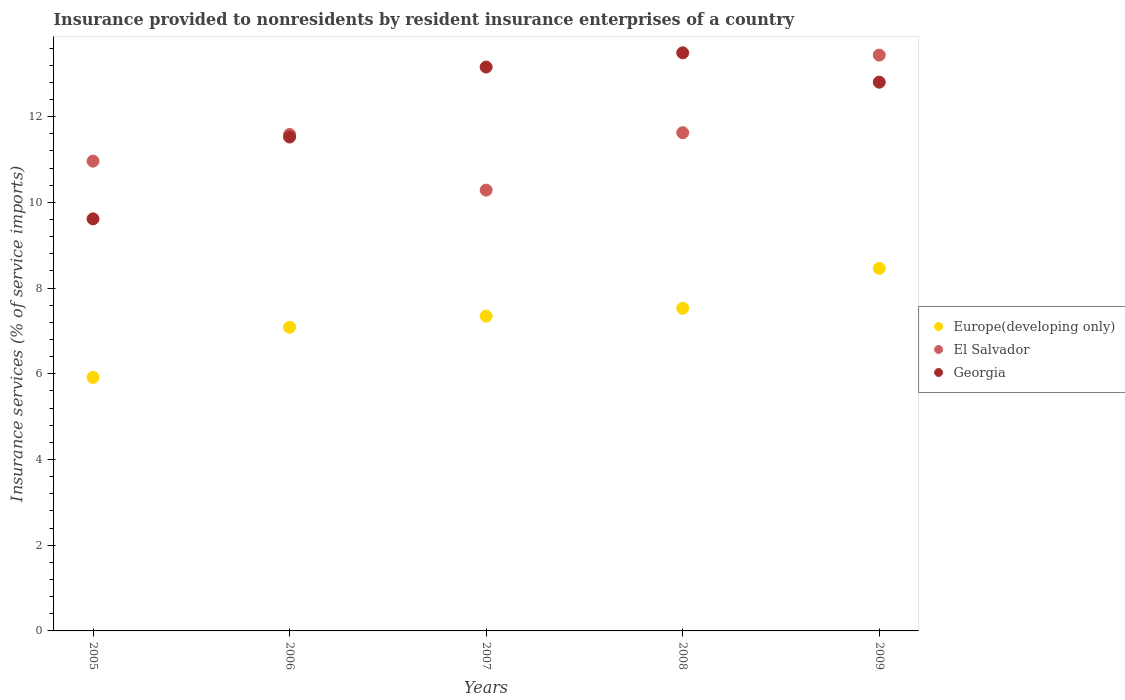How many different coloured dotlines are there?
Make the answer very short. 3. Is the number of dotlines equal to the number of legend labels?
Make the answer very short. Yes. What is the insurance provided to nonresidents in Georgia in 2007?
Provide a short and direct response. 13.16. Across all years, what is the maximum insurance provided to nonresidents in El Salvador?
Give a very brief answer. 13.44. Across all years, what is the minimum insurance provided to nonresidents in Georgia?
Offer a very short reply. 9.62. What is the total insurance provided to nonresidents in Georgia in the graph?
Offer a terse response. 60.59. What is the difference between the insurance provided to nonresidents in Europe(developing only) in 2005 and that in 2006?
Provide a short and direct response. -1.17. What is the difference between the insurance provided to nonresidents in El Salvador in 2007 and the insurance provided to nonresidents in Europe(developing only) in 2009?
Provide a short and direct response. 1.83. What is the average insurance provided to nonresidents in El Salvador per year?
Ensure brevity in your answer.  11.58. In the year 2007, what is the difference between the insurance provided to nonresidents in Georgia and insurance provided to nonresidents in El Salvador?
Your response must be concise. 2.87. What is the ratio of the insurance provided to nonresidents in El Salvador in 2008 to that in 2009?
Offer a very short reply. 0.87. What is the difference between the highest and the second highest insurance provided to nonresidents in Europe(developing only)?
Offer a very short reply. 0.93. What is the difference between the highest and the lowest insurance provided to nonresidents in El Salvador?
Your answer should be very brief. 3.15. In how many years, is the insurance provided to nonresidents in El Salvador greater than the average insurance provided to nonresidents in El Salvador taken over all years?
Offer a terse response. 3. Is the sum of the insurance provided to nonresidents in Europe(developing only) in 2007 and 2009 greater than the maximum insurance provided to nonresidents in Georgia across all years?
Make the answer very short. Yes. Is the insurance provided to nonresidents in Georgia strictly less than the insurance provided to nonresidents in Europe(developing only) over the years?
Your response must be concise. No. Are the values on the major ticks of Y-axis written in scientific E-notation?
Offer a terse response. No. Does the graph contain grids?
Your answer should be compact. No. How many legend labels are there?
Ensure brevity in your answer.  3. How are the legend labels stacked?
Offer a terse response. Vertical. What is the title of the graph?
Offer a terse response. Insurance provided to nonresidents by resident insurance enterprises of a country. Does "Brazil" appear as one of the legend labels in the graph?
Provide a short and direct response. No. What is the label or title of the X-axis?
Keep it short and to the point. Years. What is the label or title of the Y-axis?
Provide a succinct answer. Insurance services (% of service imports). What is the Insurance services (% of service imports) in Europe(developing only) in 2005?
Offer a very short reply. 5.92. What is the Insurance services (% of service imports) of El Salvador in 2005?
Ensure brevity in your answer.  10.96. What is the Insurance services (% of service imports) in Georgia in 2005?
Provide a succinct answer. 9.62. What is the Insurance services (% of service imports) in Europe(developing only) in 2006?
Give a very brief answer. 7.09. What is the Insurance services (% of service imports) in El Salvador in 2006?
Provide a succinct answer. 11.59. What is the Insurance services (% of service imports) in Georgia in 2006?
Ensure brevity in your answer.  11.53. What is the Insurance services (% of service imports) in Europe(developing only) in 2007?
Offer a very short reply. 7.34. What is the Insurance services (% of service imports) in El Salvador in 2007?
Provide a succinct answer. 10.29. What is the Insurance services (% of service imports) in Georgia in 2007?
Keep it short and to the point. 13.16. What is the Insurance services (% of service imports) of Europe(developing only) in 2008?
Your response must be concise. 7.53. What is the Insurance services (% of service imports) in El Salvador in 2008?
Ensure brevity in your answer.  11.63. What is the Insurance services (% of service imports) of Georgia in 2008?
Give a very brief answer. 13.49. What is the Insurance services (% of service imports) in Europe(developing only) in 2009?
Your answer should be compact. 8.46. What is the Insurance services (% of service imports) of El Salvador in 2009?
Your response must be concise. 13.44. What is the Insurance services (% of service imports) of Georgia in 2009?
Make the answer very short. 12.8. Across all years, what is the maximum Insurance services (% of service imports) of Europe(developing only)?
Provide a succinct answer. 8.46. Across all years, what is the maximum Insurance services (% of service imports) in El Salvador?
Your answer should be very brief. 13.44. Across all years, what is the maximum Insurance services (% of service imports) in Georgia?
Provide a succinct answer. 13.49. Across all years, what is the minimum Insurance services (% of service imports) in Europe(developing only)?
Provide a short and direct response. 5.92. Across all years, what is the minimum Insurance services (% of service imports) in El Salvador?
Keep it short and to the point. 10.29. Across all years, what is the minimum Insurance services (% of service imports) of Georgia?
Ensure brevity in your answer.  9.62. What is the total Insurance services (% of service imports) in Europe(developing only) in the graph?
Your answer should be compact. 36.34. What is the total Insurance services (% of service imports) of El Salvador in the graph?
Your answer should be very brief. 57.9. What is the total Insurance services (% of service imports) of Georgia in the graph?
Make the answer very short. 60.59. What is the difference between the Insurance services (% of service imports) of Europe(developing only) in 2005 and that in 2006?
Offer a terse response. -1.17. What is the difference between the Insurance services (% of service imports) in El Salvador in 2005 and that in 2006?
Give a very brief answer. -0.62. What is the difference between the Insurance services (% of service imports) in Georgia in 2005 and that in 2006?
Your answer should be compact. -1.91. What is the difference between the Insurance services (% of service imports) in Europe(developing only) in 2005 and that in 2007?
Keep it short and to the point. -1.43. What is the difference between the Insurance services (% of service imports) of El Salvador in 2005 and that in 2007?
Provide a succinct answer. 0.68. What is the difference between the Insurance services (% of service imports) of Georgia in 2005 and that in 2007?
Your answer should be very brief. -3.54. What is the difference between the Insurance services (% of service imports) of Europe(developing only) in 2005 and that in 2008?
Your answer should be very brief. -1.61. What is the difference between the Insurance services (% of service imports) of El Salvador in 2005 and that in 2008?
Your answer should be very brief. -0.66. What is the difference between the Insurance services (% of service imports) in Georgia in 2005 and that in 2008?
Ensure brevity in your answer.  -3.87. What is the difference between the Insurance services (% of service imports) in Europe(developing only) in 2005 and that in 2009?
Ensure brevity in your answer.  -2.54. What is the difference between the Insurance services (% of service imports) in El Salvador in 2005 and that in 2009?
Your answer should be very brief. -2.47. What is the difference between the Insurance services (% of service imports) of Georgia in 2005 and that in 2009?
Keep it short and to the point. -3.19. What is the difference between the Insurance services (% of service imports) of Europe(developing only) in 2006 and that in 2007?
Offer a very short reply. -0.26. What is the difference between the Insurance services (% of service imports) in El Salvador in 2006 and that in 2007?
Offer a very short reply. 1.3. What is the difference between the Insurance services (% of service imports) of Georgia in 2006 and that in 2007?
Make the answer very short. -1.63. What is the difference between the Insurance services (% of service imports) of Europe(developing only) in 2006 and that in 2008?
Your response must be concise. -0.44. What is the difference between the Insurance services (% of service imports) of El Salvador in 2006 and that in 2008?
Keep it short and to the point. -0.04. What is the difference between the Insurance services (% of service imports) in Georgia in 2006 and that in 2008?
Provide a short and direct response. -1.96. What is the difference between the Insurance services (% of service imports) in Europe(developing only) in 2006 and that in 2009?
Give a very brief answer. -1.37. What is the difference between the Insurance services (% of service imports) of El Salvador in 2006 and that in 2009?
Ensure brevity in your answer.  -1.85. What is the difference between the Insurance services (% of service imports) in Georgia in 2006 and that in 2009?
Offer a very short reply. -1.28. What is the difference between the Insurance services (% of service imports) of Europe(developing only) in 2007 and that in 2008?
Provide a succinct answer. -0.18. What is the difference between the Insurance services (% of service imports) of El Salvador in 2007 and that in 2008?
Provide a succinct answer. -1.34. What is the difference between the Insurance services (% of service imports) of Georgia in 2007 and that in 2008?
Give a very brief answer. -0.33. What is the difference between the Insurance services (% of service imports) in Europe(developing only) in 2007 and that in 2009?
Provide a short and direct response. -1.12. What is the difference between the Insurance services (% of service imports) in El Salvador in 2007 and that in 2009?
Your response must be concise. -3.15. What is the difference between the Insurance services (% of service imports) of Georgia in 2007 and that in 2009?
Provide a succinct answer. 0.35. What is the difference between the Insurance services (% of service imports) of Europe(developing only) in 2008 and that in 2009?
Ensure brevity in your answer.  -0.93. What is the difference between the Insurance services (% of service imports) of El Salvador in 2008 and that in 2009?
Ensure brevity in your answer.  -1.81. What is the difference between the Insurance services (% of service imports) of Georgia in 2008 and that in 2009?
Your answer should be very brief. 0.69. What is the difference between the Insurance services (% of service imports) in Europe(developing only) in 2005 and the Insurance services (% of service imports) in El Salvador in 2006?
Keep it short and to the point. -5.67. What is the difference between the Insurance services (% of service imports) of Europe(developing only) in 2005 and the Insurance services (% of service imports) of Georgia in 2006?
Ensure brevity in your answer.  -5.61. What is the difference between the Insurance services (% of service imports) of El Salvador in 2005 and the Insurance services (% of service imports) of Georgia in 2006?
Make the answer very short. -0.56. What is the difference between the Insurance services (% of service imports) of Europe(developing only) in 2005 and the Insurance services (% of service imports) of El Salvador in 2007?
Your answer should be compact. -4.37. What is the difference between the Insurance services (% of service imports) in Europe(developing only) in 2005 and the Insurance services (% of service imports) in Georgia in 2007?
Give a very brief answer. -7.24. What is the difference between the Insurance services (% of service imports) of El Salvador in 2005 and the Insurance services (% of service imports) of Georgia in 2007?
Make the answer very short. -2.2. What is the difference between the Insurance services (% of service imports) of Europe(developing only) in 2005 and the Insurance services (% of service imports) of El Salvador in 2008?
Offer a very short reply. -5.71. What is the difference between the Insurance services (% of service imports) of Europe(developing only) in 2005 and the Insurance services (% of service imports) of Georgia in 2008?
Provide a short and direct response. -7.57. What is the difference between the Insurance services (% of service imports) in El Salvador in 2005 and the Insurance services (% of service imports) in Georgia in 2008?
Your response must be concise. -2.53. What is the difference between the Insurance services (% of service imports) in Europe(developing only) in 2005 and the Insurance services (% of service imports) in El Salvador in 2009?
Offer a terse response. -7.52. What is the difference between the Insurance services (% of service imports) of Europe(developing only) in 2005 and the Insurance services (% of service imports) of Georgia in 2009?
Your answer should be compact. -6.89. What is the difference between the Insurance services (% of service imports) in El Salvador in 2005 and the Insurance services (% of service imports) in Georgia in 2009?
Provide a short and direct response. -1.84. What is the difference between the Insurance services (% of service imports) in Europe(developing only) in 2006 and the Insurance services (% of service imports) in El Salvador in 2007?
Your answer should be compact. -3.2. What is the difference between the Insurance services (% of service imports) of Europe(developing only) in 2006 and the Insurance services (% of service imports) of Georgia in 2007?
Ensure brevity in your answer.  -6.07. What is the difference between the Insurance services (% of service imports) of El Salvador in 2006 and the Insurance services (% of service imports) of Georgia in 2007?
Your answer should be compact. -1.57. What is the difference between the Insurance services (% of service imports) in Europe(developing only) in 2006 and the Insurance services (% of service imports) in El Salvador in 2008?
Provide a succinct answer. -4.54. What is the difference between the Insurance services (% of service imports) of Europe(developing only) in 2006 and the Insurance services (% of service imports) of Georgia in 2008?
Make the answer very short. -6.4. What is the difference between the Insurance services (% of service imports) of El Salvador in 2006 and the Insurance services (% of service imports) of Georgia in 2008?
Offer a very short reply. -1.9. What is the difference between the Insurance services (% of service imports) of Europe(developing only) in 2006 and the Insurance services (% of service imports) of El Salvador in 2009?
Provide a short and direct response. -6.35. What is the difference between the Insurance services (% of service imports) in Europe(developing only) in 2006 and the Insurance services (% of service imports) in Georgia in 2009?
Provide a short and direct response. -5.72. What is the difference between the Insurance services (% of service imports) of El Salvador in 2006 and the Insurance services (% of service imports) of Georgia in 2009?
Provide a short and direct response. -1.22. What is the difference between the Insurance services (% of service imports) in Europe(developing only) in 2007 and the Insurance services (% of service imports) in El Salvador in 2008?
Your answer should be very brief. -4.28. What is the difference between the Insurance services (% of service imports) of Europe(developing only) in 2007 and the Insurance services (% of service imports) of Georgia in 2008?
Make the answer very short. -6.15. What is the difference between the Insurance services (% of service imports) of El Salvador in 2007 and the Insurance services (% of service imports) of Georgia in 2008?
Your answer should be compact. -3.2. What is the difference between the Insurance services (% of service imports) of Europe(developing only) in 2007 and the Insurance services (% of service imports) of El Salvador in 2009?
Offer a very short reply. -6.09. What is the difference between the Insurance services (% of service imports) in Europe(developing only) in 2007 and the Insurance services (% of service imports) in Georgia in 2009?
Keep it short and to the point. -5.46. What is the difference between the Insurance services (% of service imports) of El Salvador in 2007 and the Insurance services (% of service imports) of Georgia in 2009?
Offer a very short reply. -2.52. What is the difference between the Insurance services (% of service imports) in Europe(developing only) in 2008 and the Insurance services (% of service imports) in El Salvador in 2009?
Your answer should be compact. -5.91. What is the difference between the Insurance services (% of service imports) of Europe(developing only) in 2008 and the Insurance services (% of service imports) of Georgia in 2009?
Your answer should be very brief. -5.28. What is the difference between the Insurance services (% of service imports) in El Salvador in 2008 and the Insurance services (% of service imports) in Georgia in 2009?
Provide a short and direct response. -1.18. What is the average Insurance services (% of service imports) of Europe(developing only) per year?
Give a very brief answer. 7.27. What is the average Insurance services (% of service imports) in El Salvador per year?
Provide a succinct answer. 11.58. What is the average Insurance services (% of service imports) in Georgia per year?
Provide a succinct answer. 12.12. In the year 2005, what is the difference between the Insurance services (% of service imports) in Europe(developing only) and Insurance services (% of service imports) in El Salvador?
Make the answer very short. -5.05. In the year 2005, what is the difference between the Insurance services (% of service imports) in Europe(developing only) and Insurance services (% of service imports) in Georgia?
Offer a terse response. -3.7. In the year 2005, what is the difference between the Insurance services (% of service imports) of El Salvador and Insurance services (% of service imports) of Georgia?
Your answer should be compact. 1.35. In the year 2006, what is the difference between the Insurance services (% of service imports) of Europe(developing only) and Insurance services (% of service imports) of Georgia?
Your answer should be compact. -4.44. In the year 2006, what is the difference between the Insurance services (% of service imports) of El Salvador and Insurance services (% of service imports) of Georgia?
Provide a short and direct response. 0.06. In the year 2007, what is the difference between the Insurance services (% of service imports) in Europe(developing only) and Insurance services (% of service imports) in El Salvador?
Ensure brevity in your answer.  -2.94. In the year 2007, what is the difference between the Insurance services (% of service imports) in Europe(developing only) and Insurance services (% of service imports) in Georgia?
Give a very brief answer. -5.81. In the year 2007, what is the difference between the Insurance services (% of service imports) in El Salvador and Insurance services (% of service imports) in Georgia?
Your answer should be very brief. -2.87. In the year 2008, what is the difference between the Insurance services (% of service imports) in Europe(developing only) and Insurance services (% of service imports) in El Salvador?
Your response must be concise. -4.1. In the year 2008, what is the difference between the Insurance services (% of service imports) of Europe(developing only) and Insurance services (% of service imports) of Georgia?
Your answer should be very brief. -5.96. In the year 2008, what is the difference between the Insurance services (% of service imports) of El Salvador and Insurance services (% of service imports) of Georgia?
Offer a very short reply. -1.86. In the year 2009, what is the difference between the Insurance services (% of service imports) of Europe(developing only) and Insurance services (% of service imports) of El Salvador?
Ensure brevity in your answer.  -4.98. In the year 2009, what is the difference between the Insurance services (% of service imports) of Europe(developing only) and Insurance services (% of service imports) of Georgia?
Make the answer very short. -4.34. In the year 2009, what is the difference between the Insurance services (% of service imports) in El Salvador and Insurance services (% of service imports) in Georgia?
Offer a terse response. 0.63. What is the ratio of the Insurance services (% of service imports) of Europe(developing only) in 2005 to that in 2006?
Ensure brevity in your answer.  0.84. What is the ratio of the Insurance services (% of service imports) of El Salvador in 2005 to that in 2006?
Offer a very short reply. 0.95. What is the ratio of the Insurance services (% of service imports) in Georgia in 2005 to that in 2006?
Your answer should be very brief. 0.83. What is the ratio of the Insurance services (% of service imports) of Europe(developing only) in 2005 to that in 2007?
Your answer should be compact. 0.81. What is the ratio of the Insurance services (% of service imports) of El Salvador in 2005 to that in 2007?
Provide a short and direct response. 1.07. What is the ratio of the Insurance services (% of service imports) in Georgia in 2005 to that in 2007?
Ensure brevity in your answer.  0.73. What is the ratio of the Insurance services (% of service imports) in Europe(developing only) in 2005 to that in 2008?
Make the answer very short. 0.79. What is the ratio of the Insurance services (% of service imports) of El Salvador in 2005 to that in 2008?
Your response must be concise. 0.94. What is the ratio of the Insurance services (% of service imports) in Georgia in 2005 to that in 2008?
Offer a very short reply. 0.71. What is the ratio of the Insurance services (% of service imports) of Europe(developing only) in 2005 to that in 2009?
Make the answer very short. 0.7. What is the ratio of the Insurance services (% of service imports) of El Salvador in 2005 to that in 2009?
Your response must be concise. 0.82. What is the ratio of the Insurance services (% of service imports) in Georgia in 2005 to that in 2009?
Give a very brief answer. 0.75. What is the ratio of the Insurance services (% of service imports) in Europe(developing only) in 2006 to that in 2007?
Offer a terse response. 0.96. What is the ratio of the Insurance services (% of service imports) in El Salvador in 2006 to that in 2007?
Your answer should be very brief. 1.13. What is the ratio of the Insurance services (% of service imports) of Georgia in 2006 to that in 2007?
Offer a very short reply. 0.88. What is the ratio of the Insurance services (% of service imports) of Europe(developing only) in 2006 to that in 2008?
Provide a short and direct response. 0.94. What is the ratio of the Insurance services (% of service imports) in El Salvador in 2006 to that in 2008?
Your answer should be very brief. 1. What is the ratio of the Insurance services (% of service imports) of Georgia in 2006 to that in 2008?
Offer a very short reply. 0.85. What is the ratio of the Insurance services (% of service imports) of Europe(developing only) in 2006 to that in 2009?
Your answer should be very brief. 0.84. What is the ratio of the Insurance services (% of service imports) in El Salvador in 2006 to that in 2009?
Offer a terse response. 0.86. What is the ratio of the Insurance services (% of service imports) of Georgia in 2006 to that in 2009?
Keep it short and to the point. 0.9. What is the ratio of the Insurance services (% of service imports) of Europe(developing only) in 2007 to that in 2008?
Ensure brevity in your answer.  0.98. What is the ratio of the Insurance services (% of service imports) in El Salvador in 2007 to that in 2008?
Offer a terse response. 0.88. What is the ratio of the Insurance services (% of service imports) of Georgia in 2007 to that in 2008?
Your response must be concise. 0.98. What is the ratio of the Insurance services (% of service imports) in Europe(developing only) in 2007 to that in 2009?
Ensure brevity in your answer.  0.87. What is the ratio of the Insurance services (% of service imports) of El Salvador in 2007 to that in 2009?
Make the answer very short. 0.77. What is the ratio of the Insurance services (% of service imports) of Georgia in 2007 to that in 2009?
Keep it short and to the point. 1.03. What is the ratio of the Insurance services (% of service imports) of Europe(developing only) in 2008 to that in 2009?
Provide a succinct answer. 0.89. What is the ratio of the Insurance services (% of service imports) of El Salvador in 2008 to that in 2009?
Keep it short and to the point. 0.87. What is the ratio of the Insurance services (% of service imports) in Georgia in 2008 to that in 2009?
Offer a terse response. 1.05. What is the difference between the highest and the second highest Insurance services (% of service imports) in Europe(developing only)?
Your answer should be very brief. 0.93. What is the difference between the highest and the second highest Insurance services (% of service imports) of El Salvador?
Give a very brief answer. 1.81. What is the difference between the highest and the second highest Insurance services (% of service imports) of Georgia?
Ensure brevity in your answer.  0.33. What is the difference between the highest and the lowest Insurance services (% of service imports) of Europe(developing only)?
Offer a very short reply. 2.54. What is the difference between the highest and the lowest Insurance services (% of service imports) of El Salvador?
Ensure brevity in your answer.  3.15. What is the difference between the highest and the lowest Insurance services (% of service imports) of Georgia?
Your answer should be compact. 3.87. 